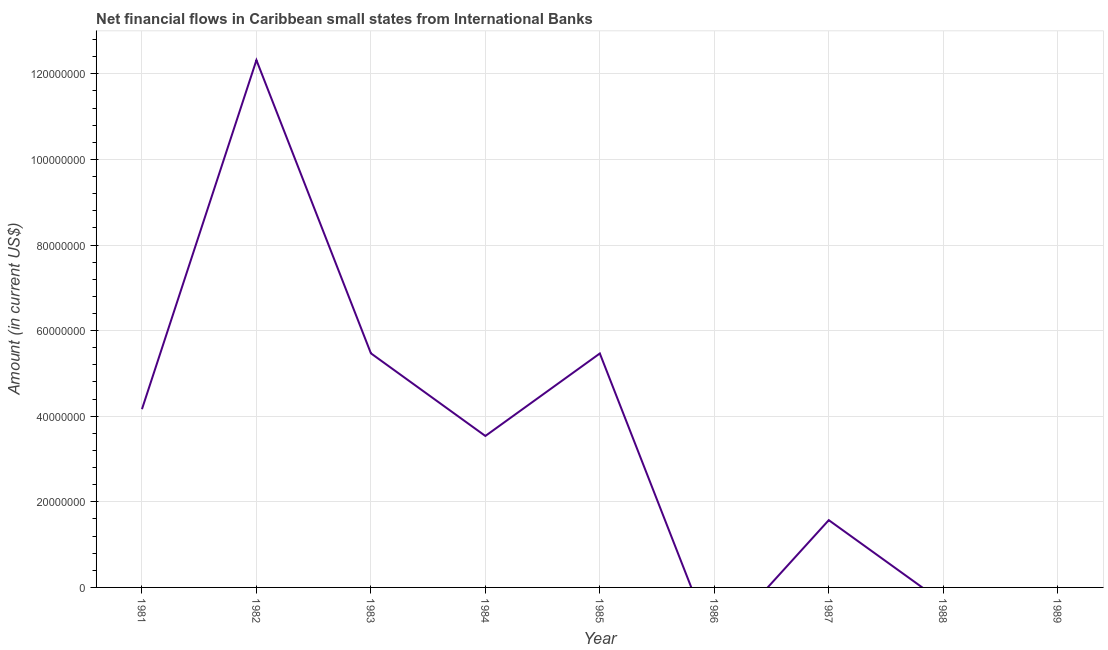What is the net financial flows from ibrd in 1988?
Your answer should be compact. 0. Across all years, what is the maximum net financial flows from ibrd?
Provide a succinct answer. 1.23e+08. In which year was the net financial flows from ibrd maximum?
Provide a succinct answer. 1982. What is the sum of the net financial flows from ibrd?
Your answer should be very brief. 3.25e+08. What is the difference between the net financial flows from ibrd in 1981 and 1982?
Give a very brief answer. -8.16e+07. What is the average net financial flows from ibrd per year?
Offer a terse response. 3.61e+07. What is the median net financial flows from ibrd?
Offer a terse response. 3.54e+07. What is the ratio of the net financial flows from ibrd in 1985 to that in 1987?
Your answer should be compact. 3.48. Is the difference between the net financial flows from ibrd in 1981 and 1983 greater than the difference between any two years?
Keep it short and to the point. No. What is the difference between the highest and the second highest net financial flows from ibrd?
Offer a terse response. 6.85e+07. What is the difference between the highest and the lowest net financial flows from ibrd?
Your answer should be compact. 1.23e+08. Does the net financial flows from ibrd monotonically increase over the years?
Give a very brief answer. No. How many years are there in the graph?
Ensure brevity in your answer.  9. Does the graph contain any zero values?
Your answer should be compact. Yes. Does the graph contain grids?
Provide a succinct answer. Yes. What is the title of the graph?
Keep it short and to the point. Net financial flows in Caribbean small states from International Banks. What is the label or title of the Y-axis?
Make the answer very short. Amount (in current US$). What is the Amount (in current US$) in 1981?
Make the answer very short. 4.16e+07. What is the Amount (in current US$) in 1982?
Your answer should be very brief. 1.23e+08. What is the Amount (in current US$) of 1983?
Offer a very short reply. 5.47e+07. What is the Amount (in current US$) in 1984?
Offer a very short reply. 3.54e+07. What is the Amount (in current US$) in 1985?
Your response must be concise. 5.47e+07. What is the Amount (in current US$) in 1987?
Provide a succinct answer. 1.57e+07. What is the difference between the Amount (in current US$) in 1981 and 1982?
Offer a very short reply. -8.16e+07. What is the difference between the Amount (in current US$) in 1981 and 1983?
Provide a succinct answer. -1.31e+07. What is the difference between the Amount (in current US$) in 1981 and 1984?
Offer a very short reply. 6.26e+06. What is the difference between the Amount (in current US$) in 1981 and 1985?
Your answer should be compact. -1.30e+07. What is the difference between the Amount (in current US$) in 1981 and 1987?
Make the answer very short. 2.59e+07. What is the difference between the Amount (in current US$) in 1982 and 1983?
Offer a terse response. 6.85e+07. What is the difference between the Amount (in current US$) in 1982 and 1984?
Offer a very short reply. 8.78e+07. What is the difference between the Amount (in current US$) in 1982 and 1985?
Keep it short and to the point. 6.85e+07. What is the difference between the Amount (in current US$) in 1982 and 1987?
Your answer should be very brief. 1.07e+08. What is the difference between the Amount (in current US$) in 1983 and 1984?
Provide a short and direct response. 1.93e+07. What is the difference between the Amount (in current US$) in 1983 and 1985?
Make the answer very short. 3.59e+04. What is the difference between the Amount (in current US$) in 1983 and 1987?
Your answer should be compact. 3.90e+07. What is the difference between the Amount (in current US$) in 1984 and 1985?
Make the answer very short. -1.93e+07. What is the difference between the Amount (in current US$) in 1984 and 1987?
Your answer should be compact. 1.97e+07. What is the difference between the Amount (in current US$) in 1985 and 1987?
Keep it short and to the point. 3.89e+07. What is the ratio of the Amount (in current US$) in 1981 to that in 1982?
Offer a very short reply. 0.34. What is the ratio of the Amount (in current US$) in 1981 to that in 1983?
Your answer should be compact. 0.76. What is the ratio of the Amount (in current US$) in 1981 to that in 1984?
Offer a very short reply. 1.18. What is the ratio of the Amount (in current US$) in 1981 to that in 1985?
Provide a succinct answer. 0.76. What is the ratio of the Amount (in current US$) in 1981 to that in 1987?
Offer a very short reply. 2.65. What is the ratio of the Amount (in current US$) in 1982 to that in 1983?
Provide a short and direct response. 2.25. What is the ratio of the Amount (in current US$) in 1982 to that in 1984?
Offer a terse response. 3.48. What is the ratio of the Amount (in current US$) in 1982 to that in 1985?
Keep it short and to the point. 2.25. What is the ratio of the Amount (in current US$) in 1982 to that in 1987?
Ensure brevity in your answer.  7.84. What is the ratio of the Amount (in current US$) in 1983 to that in 1984?
Your answer should be compact. 1.55. What is the ratio of the Amount (in current US$) in 1983 to that in 1985?
Offer a terse response. 1. What is the ratio of the Amount (in current US$) in 1983 to that in 1987?
Your answer should be very brief. 3.48. What is the ratio of the Amount (in current US$) in 1984 to that in 1985?
Offer a terse response. 0.65. What is the ratio of the Amount (in current US$) in 1984 to that in 1987?
Offer a terse response. 2.25. What is the ratio of the Amount (in current US$) in 1985 to that in 1987?
Provide a succinct answer. 3.48. 